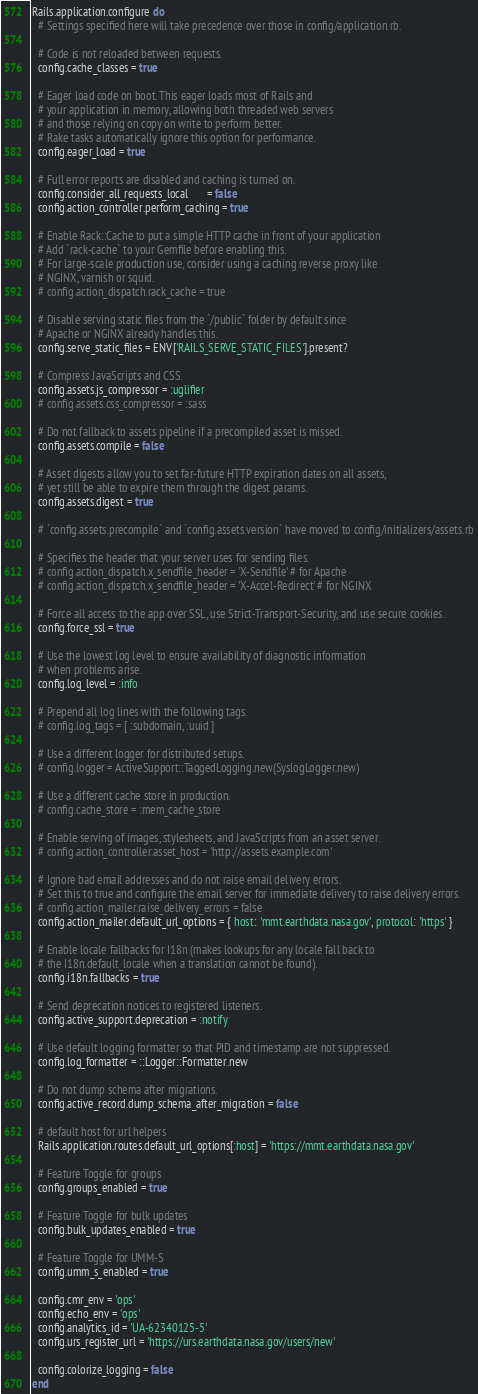Convert code to text. <code><loc_0><loc_0><loc_500><loc_500><_Ruby_>Rails.application.configure do
  # Settings specified here will take precedence over those in config/application.rb.

  # Code is not reloaded between requests.
  config.cache_classes = true

  # Eager load code on boot. This eager loads most of Rails and
  # your application in memory, allowing both threaded web servers
  # and those relying on copy on write to perform better.
  # Rake tasks automatically ignore this option for performance.
  config.eager_load = true

  # Full error reports are disabled and caching is turned on.
  config.consider_all_requests_local       = false
  config.action_controller.perform_caching = true

  # Enable Rack::Cache to put a simple HTTP cache in front of your application
  # Add `rack-cache` to your Gemfile before enabling this.
  # For large-scale production use, consider using a caching reverse proxy like
  # NGINX, varnish or squid.
  # config.action_dispatch.rack_cache = true

  # Disable serving static files from the `/public` folder by default since
  # Apache or NGINX already handles this.
  config.serve_static_files = ENV['RAILS_SERVE_STATIC_FILES'].present?

  # Compress JavaScripts and CSS.
  config.assets.js_compressor = :uglifier
  # config.assets.css_compressor = :sass

  # Do not fallback to assets pipeline if a precompiled asset is missed.
  config.assets.compile = false

  # Asset digests allow you to set far-future HTTP expiration dates on all assets,
  # yet still be able to expire them through the digest params.
  config.assets.digest = true

  # `config.assets.precompile` and `config.assets.version` have moved to config/initializers/assets.rb

  # Specifies the header that your server uses for sending files.
  # config.action_dispatch.x_sendfile_header = 'X-Sendfile' # for Apache
  # config.action_dispatch.x_sendfile_header = 'X-Accel-Redirect' # for NGINX

  # Force all access to the app over SSL, use Strict-Transport-Security, and use secure cookies.
  config.force_ssl = true

  # Use the lowest log level to ensure availability of diagnostic information
  # when problems arise.
  config.log_level = :info

  # Prepend all log lines with the following tags.
  # config.log_tags = [ :subdomain, :uuid ]

  # Use a different logger for distributed setups.
  # config.logger = ActiveSupport::TaggedLogging.new(SyslogLogger.new)

  # Use a different cache store in production.
  # config.cache_store = :mem_cache_store

  # Enable serving of images, stylesheets, and JavaScripts from an asset server.
  # config.action_controller.asset_host = 'http://assets.example.com'

  # Ignore bad email addresses and do not raise email delivery errors.
  # Set this to true and configure the email server for immediate delivery to raise delivery errors.
  # config.action_mailer.raise_delivery_errors = false
  config.action_mailer.default_url_options = { host: 'mmt.earthdata.nasa.gov', protocol: 'https' }

  # Enable locale fallbacks for I18n (makes lookups for any locale fall back to
  # the I18n.default_locale when a translation cannot be found).
  config.i18n.fallbacks = true

  # Send deprecation notices to registered listeners.
  config.active_support.deprecation = :notify

  # Use default logging formatter so that PID and timestamp are not suppressed.
  config.log_formatter = ::Logger::Formatter.new

  # Do not dump schema after migrations.
  config.active_record.dump_schema_after_migration = false

  # default host for url helpers
  Rails.application.routes.default_url_options[:host] = 'https://mmt.earthdata.nasa.gov'

  # Feature Toggle for groups
  config.groups_enabled = true

  # Feature Toggle for bulk updates
  config.bulk_updates_enabled = true

  # Feature Toggle for UMM-S
  config.umm_s_enabled = true

  config.cmr_env = 'ops'
  config.echo_env = 'ops'
  config.analytics_id = 'UA-62340125-5'
  config.urs_register_url = 'https://urs.earthdata.nasa.gov/users/new'

  config.colorize_logging = false
end
</code> 